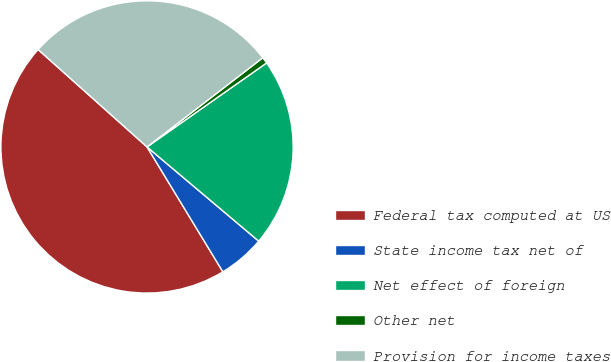Convert chart. <chart><loc_0><loc_0><loc_500><loc_500><pie_chart><fcel>Federal tax computed at US<fcel>State income tax net of<fcel>Net effect of foreign<fcel>Other net<fcel>Provision for income taxes<nl><fcel>45.3%<fcel>5.16%<fcel>20.9%<fcel>0.7%<fcel>27.94%<nl></chart> 